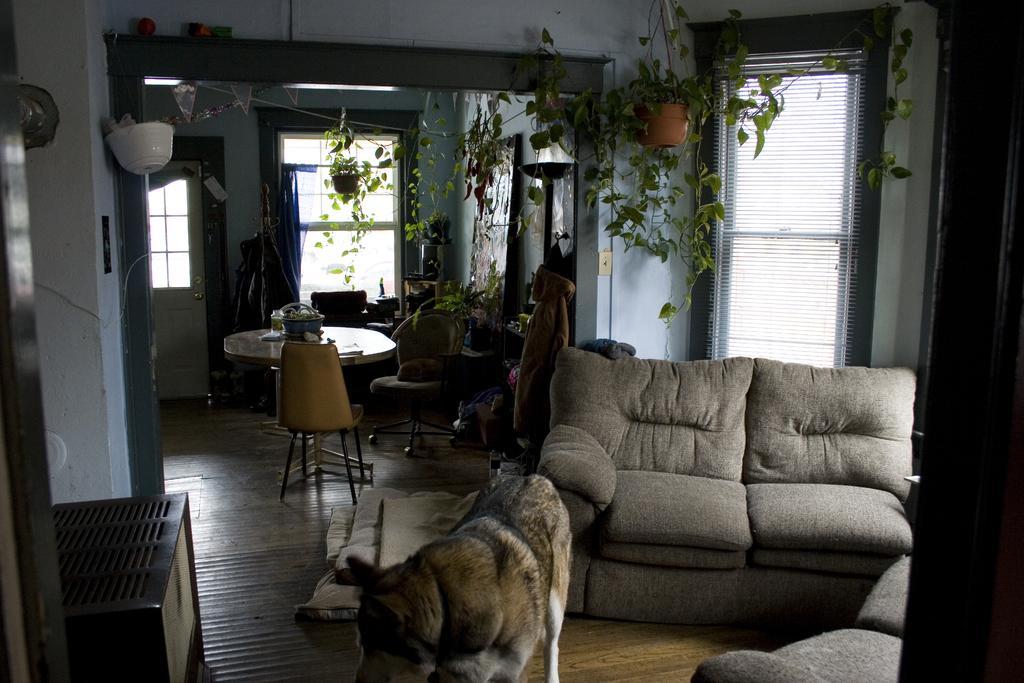Please provide a concise description of this image. In this picture we can see a room with sofa, dog standing on floor and in background we can see table and on table there is basket, windows, flower pot with plants in it, wall, jacket, door, pillar. 